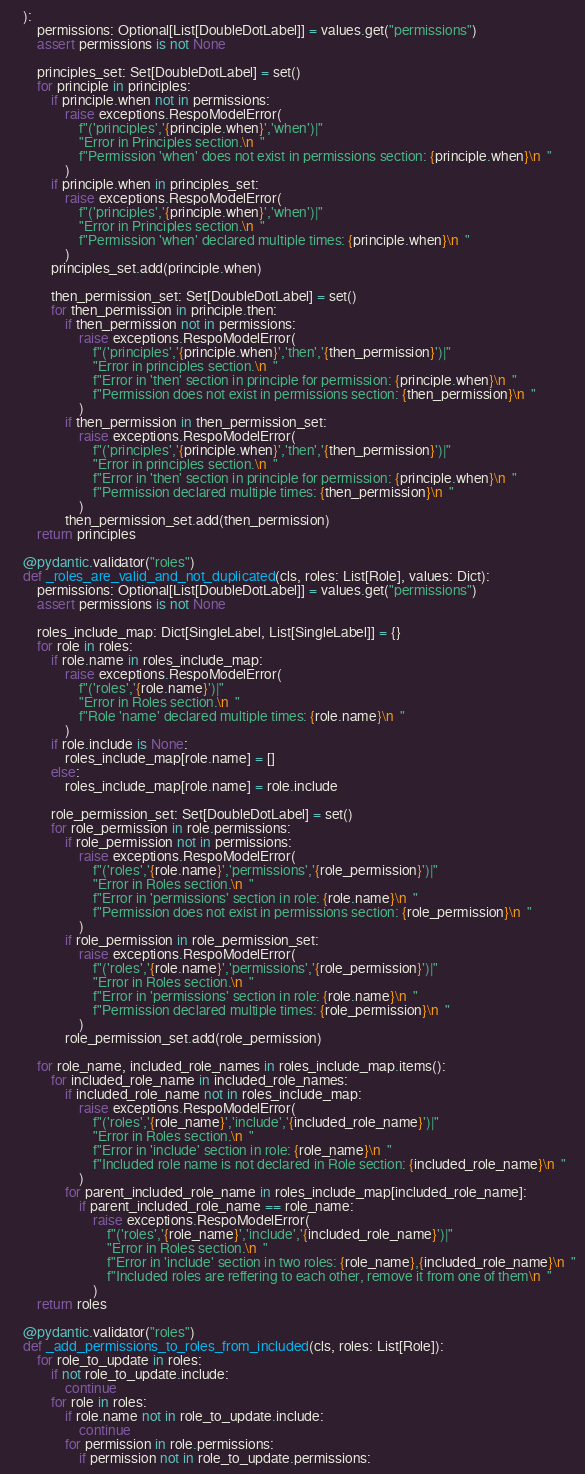Convert code to text. <code><loc_0><loc_0><loc_500><loc_500><_Python_>    ):
        permissions: Optional[List[DoubleDotLabel]] = values.get("permissions")
        assert permissions is not None

        principles_set: Set[DoubleDotLabel] = set()
        for principle in principles:
            if principle.when not in permissions:
                raise exceptions.RespoModelError(
                    f"('principles','{principle.when}','when')|"
                    "Error in Principles section.\n  "
                    f"Permission 'when' does not exist in permissions section: {principle.when}\n  "
                )
            if principle.when in principles_set:
                raise exceptions.RespoModelError(
                    f"('principles','{principle.when}','when')|"
                    "Error in Principles section.\n  "
                    f"Permission 'when' declared multiple times: {principle.when}\n  "
                )
            principles_set.add(principle.when)

            then_permission_set: Set[DoubleDotLabel] = set()
            for then_permission in principle.then:
                if then_permission not in permissions:
                    raise exceptions.RespoModelError(
                        f"('principles','{principle.when}','then','{then_permission}')|"
                        "Error in principles section.\n  "
                        f"Error in 'then' section in principle for permission: {principle.when}\n  "
                        f"Permission does not exist in permissions section: {then_permission}\n  "
                    )
                if then_permission in then_permission_set:
                    raise exceptions.RespoModelError(
                        f"('principles','{principle.when}','then','{then_permission}')|"
                        "Error in principles section.\n  "
                        f"Error in 'then' section in principle for permission: {principle.when}\n  "
                        f"Permission declared multiple times: {then_permission}\n  "
                    )
                then_permission_set.add(then_permission)
        return principles

    @pydantic.validator("roles")
    def _roles_are_valid_and_not_duplicated(cls, roles: List[Role], values: Dict):
        permissions: Optional[List[DoubleDotLabel]] = values.get("permissions")
        assert permissions is not None

        roles_include_map: Dict[SingleLabel, List[SingleLabel]] = {}
        for role in roles:
            if role.name in roles_include_map:
                raise exceptions.RespoModelError(
                    f"('roles','{role.name}')|"
                    "Error in Roles section.\n  "
                    f"Role 'name' declared multiple times: {role.name}\n  "
                )
            if role.include is None:
                roles_include_map[role.name] = []
            else:
                roles_include_map[role.name] = role.include

            role_permission_set: Set[DoubleDotLabel] = set()
            for role_permission in role.permissions:
                if role_permission not in permissions:
                    raise exceptions.RespoModelError(
                        f"('roles','{role.name}','permissions','{role_permission}')|"
                        "Error in Roles section.\n  "
                        f"Error in 'permissions' section in role: {role.name}\n  "
                        f"Permission does not exist in permissions section: {role_permission}\n  "
                    )
                if role_permission in role_permission_set:
                    raise exceptions.RespoModelError(
                        f"('roles','{role.name}','permissions','{role_permission}')|"
                        "Error in Roles section.\n  "
                        f"Error in 'permissions' section in role: {role.name}\n  "
                        f"Permission declared multiple times: {role_permission}\n  "
                    )
                role_permission_set.add(role_permission)

        for role_name, included_role_names in roles_include_map.items():
            for included_role_name in included_role_names:
                if included_role_name not in roles_include_map:
                    raise exceptions.RespoModelError(
                        f"('roles','{role_name}','include','{included_role_name}')|"
                        "Error in Roles section.\n  "
                        f"Error in 'include' section in role: {role_name}\n  "
                        f"Included role name is not declared in Role section: {included_role_name}\n  "
                    )
                for parent_included_role_name in roles_include_map[included_role_name]:
                    if parent_included_role_name == role_name:
                        raise exceptions.RespoModelError(
                            f"('roles','{role_name}','include','{included_role_name}')|"
                            "Error in Roles section.\n  "
                            f"Error in 'include' section in two roles: {role_name},{included_role_name}\n  "
                            f"Included roles are reffering to each other, remove it from one of them\n  "
                        )
        return roles

    @pydantic.validator("roles")
    def _add_permissions_to_roles_from_included(cls, roles: List[Role]):
        for role_to_update in roles:
            if not role_to_update.include:
                continue
            for role in roles:
                if role.name not in role_to_update.include:
                    continue
                for permission in role.permissions:
                    if permission not in role_to_update.permissions:</code> 